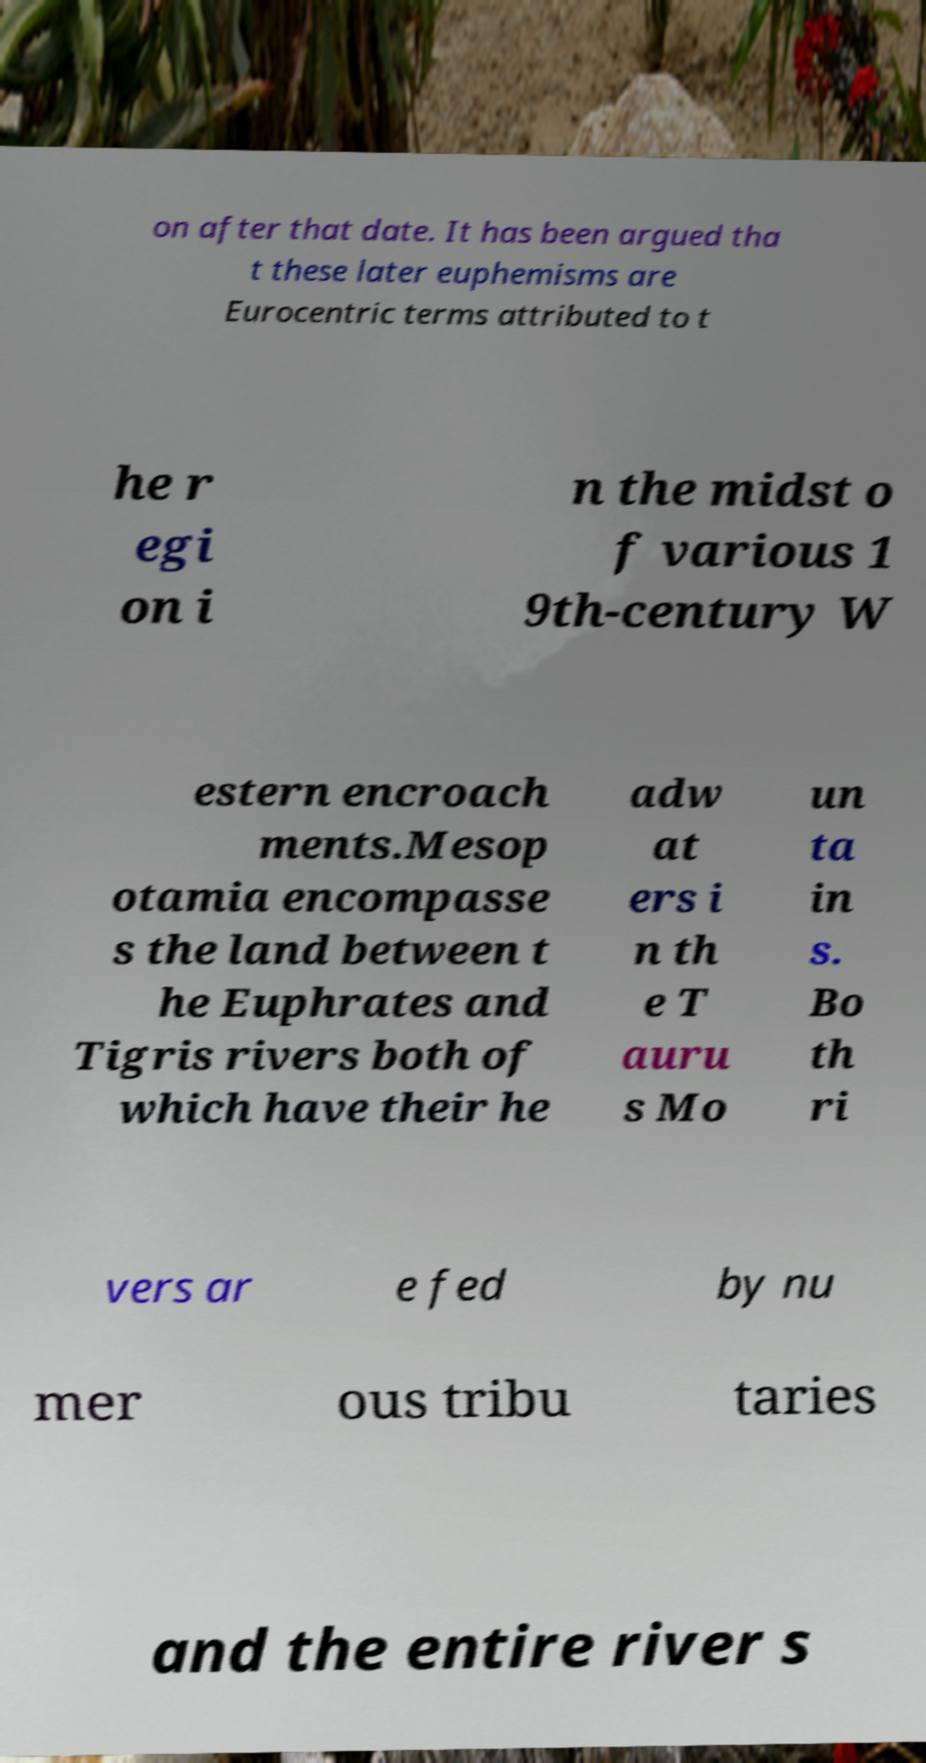Please read and relay the text visible in this image. What does it say? on after that date. It has been argued tha t these later euphemisms are Eurocentric terms attributed to t he r egi on i n the midst o f various 1 9th-century W estern encroach ments.Mesop otamia encompasse s the land between t he Euphrates and Tigris rivers both of which have their he adw at ers i n th e T auru s Mo un ta in s. Bo th ri vers ar e fed by nu mer ous tribu taries and the entire river s 